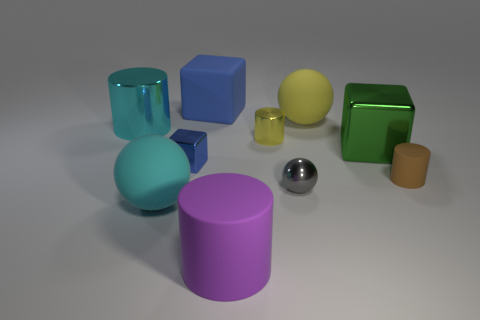Subtract all blocks. How many objects are left? 7 Add 1 small cyan cubes. How many small cyan cubes exist? 1 Subtract 0 green cylinders. How many objects are left? 10 Subtract all big balls. Subtract all large metal things. How many objects are left? 6 Add 3 big cylinders. How many big cylinders are left? 5 